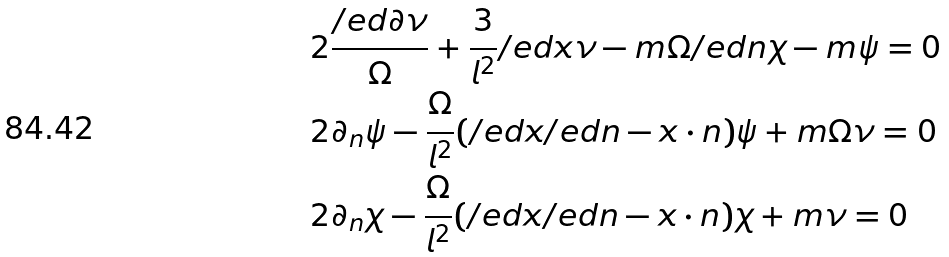<formula> <loc_0><loc_0><loc_500><loc_500>& 2 \frac { \slash e d \partial \nu } \Omega + \frac { 3 } { l ^ { 2 } } \slash e d x \nu - m \Omega \slash e d n \chi - m \psi = 0 \\ & 2 \partial _ { n } \psi - \frac { \Omega } { l ^ { 2 } } ( \slash e d x \slash e d n - x \cdot n ) \psi + m \Omega \nu = 0 \\ & 2 \partial _ { n } \chi - \frac { \Omega } { l ^ { 2 } } ( \slash e d x \slash e d n - x \cdot n ) \chi + m \nu = 0</formula> 